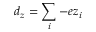<formula> <loc_0><loc_0><loc_500><loc_500>d _ { z } = \sum _ { i } - e z _ { i }</formula> 